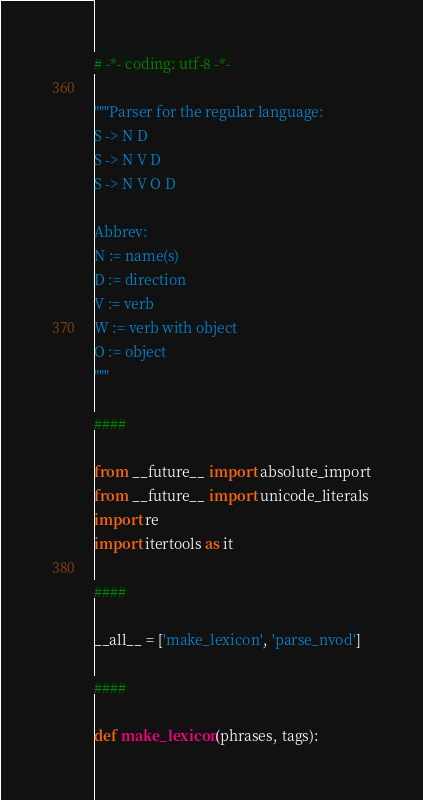<code> <loc_0><loc_0><loc_500><loc_500><_Python_># -*- coding: utf-8 -*-

"""Parser for the regular language:
S -> N D
S -> N V D
S -> N V O D

Abbrev:
N := name(s)
D := direction
V := verb
W := verb with object
O := object
"""

####

from __future__ import absolute_import
from __future__ import unicode_literals
import re
import itertools as it

####

__all__ = ['make_lexicon', 'parse_nvod']

####

def make_lexicon(phrases, tags):
</code> 